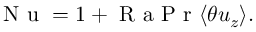Convert formula to latex. <formula><loc_0><loc_0><loc_500><loc_500>N u = 1 + R a P r \langle \theta u _ { z } \rangle .</formula> 